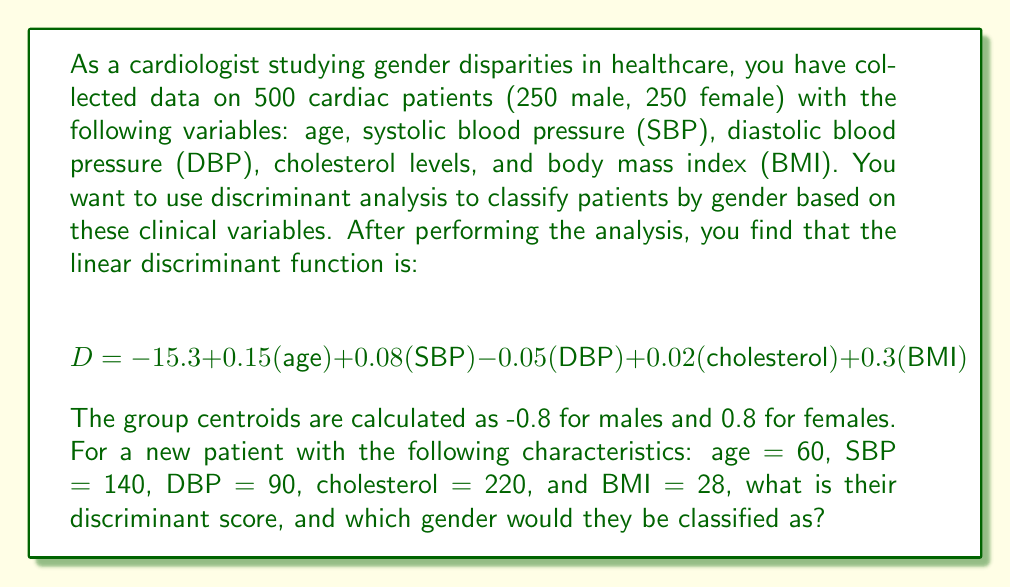Give your solution to this math problem. To solve this problem, we need to follow these steps:

1. Calculate the discriminant score (D) for the new patient using the given linear discriminant function.
2. Compare the calculated D value to the group centroids to determine the classification.

Step 1: Calculate the discriminant score

We'll substitute the patient's values into the discriminant function:

$$ \begin{align}
D &= -15.3 + 0.15(\text{age}) + 0.08(\text{SBP}) - 0.05(\text{DBP}) + 0.02(\text{cholesterol}) + 0.3(\text{BMI}) \\
&= -15.3 + 0.15(60) + 0.08(140) - 0.05(90) + 0.02(220) + 0.3(28) \\
&= -15.3 + 9 + 11.2 - 4.5 + 4.4 + 8.4 \\
&= 13.2
\end{align} $$

Step 2: Compare to group centroids

The group centroids are:
- Males: -0.8
- Females: 0.8

The calculated D value (13.2) is closer to the female centroid (0.8) than the male centroid (-0.8). In fact, it's higher than both centroids, but it's on the same side of the decision boundary as the female centroid.

To classify, we typically use the midpoint between the two centroids as the decision boundary. In this case, the midpoint is:

$$ \frac{-0.8 + 0.8}{2} = 0 $$

Since 13.2 > 0, the patient would be classified as female.
Answer: The discriminant score for the new patient is 13.2, and they would be classified as female. 